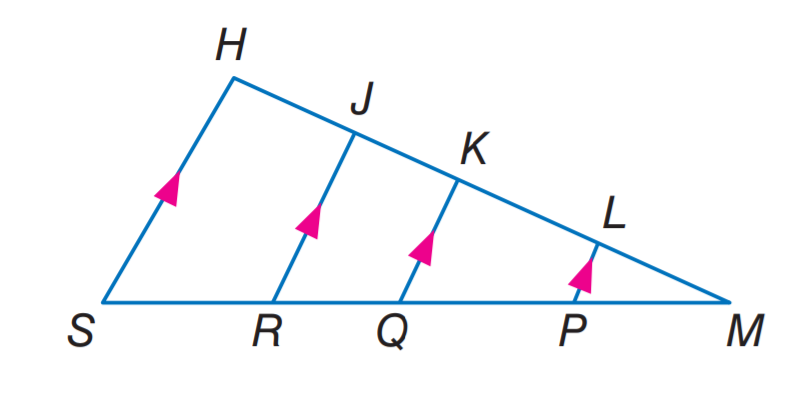Answer the mathemtical geometry problem and directly provide the correct option letter.
Question: If L K = 4, M P = 3, P Q = 6, K J = 2, R S = 6, and L P = 2, find Q R.
Choices: A: 2 B: 3 C: 4 D: 6 B 